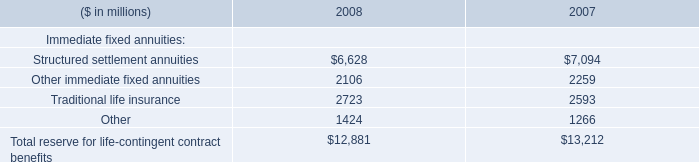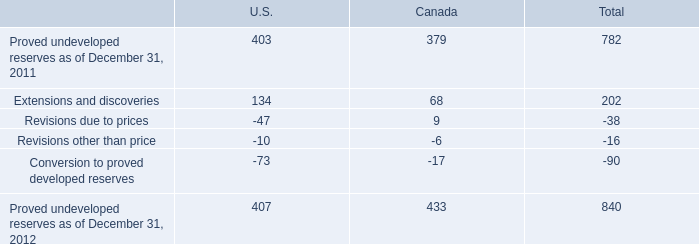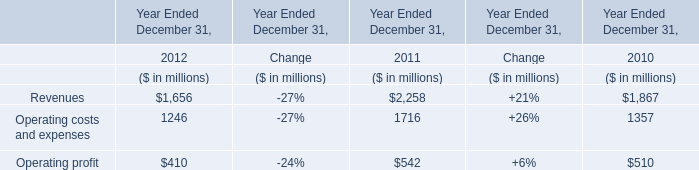what percentage of total proved undeveloped reserves from canada from 2011-2012 was its proved undeveloped reserves as of dec 31 , 2011? 
Computations: ((379 / (379 + 433)) * 100)
Answer: 46.67488. What's the increasing rate of Operating profit in 2011 Ended December 31? 
Answer: 0.06. 